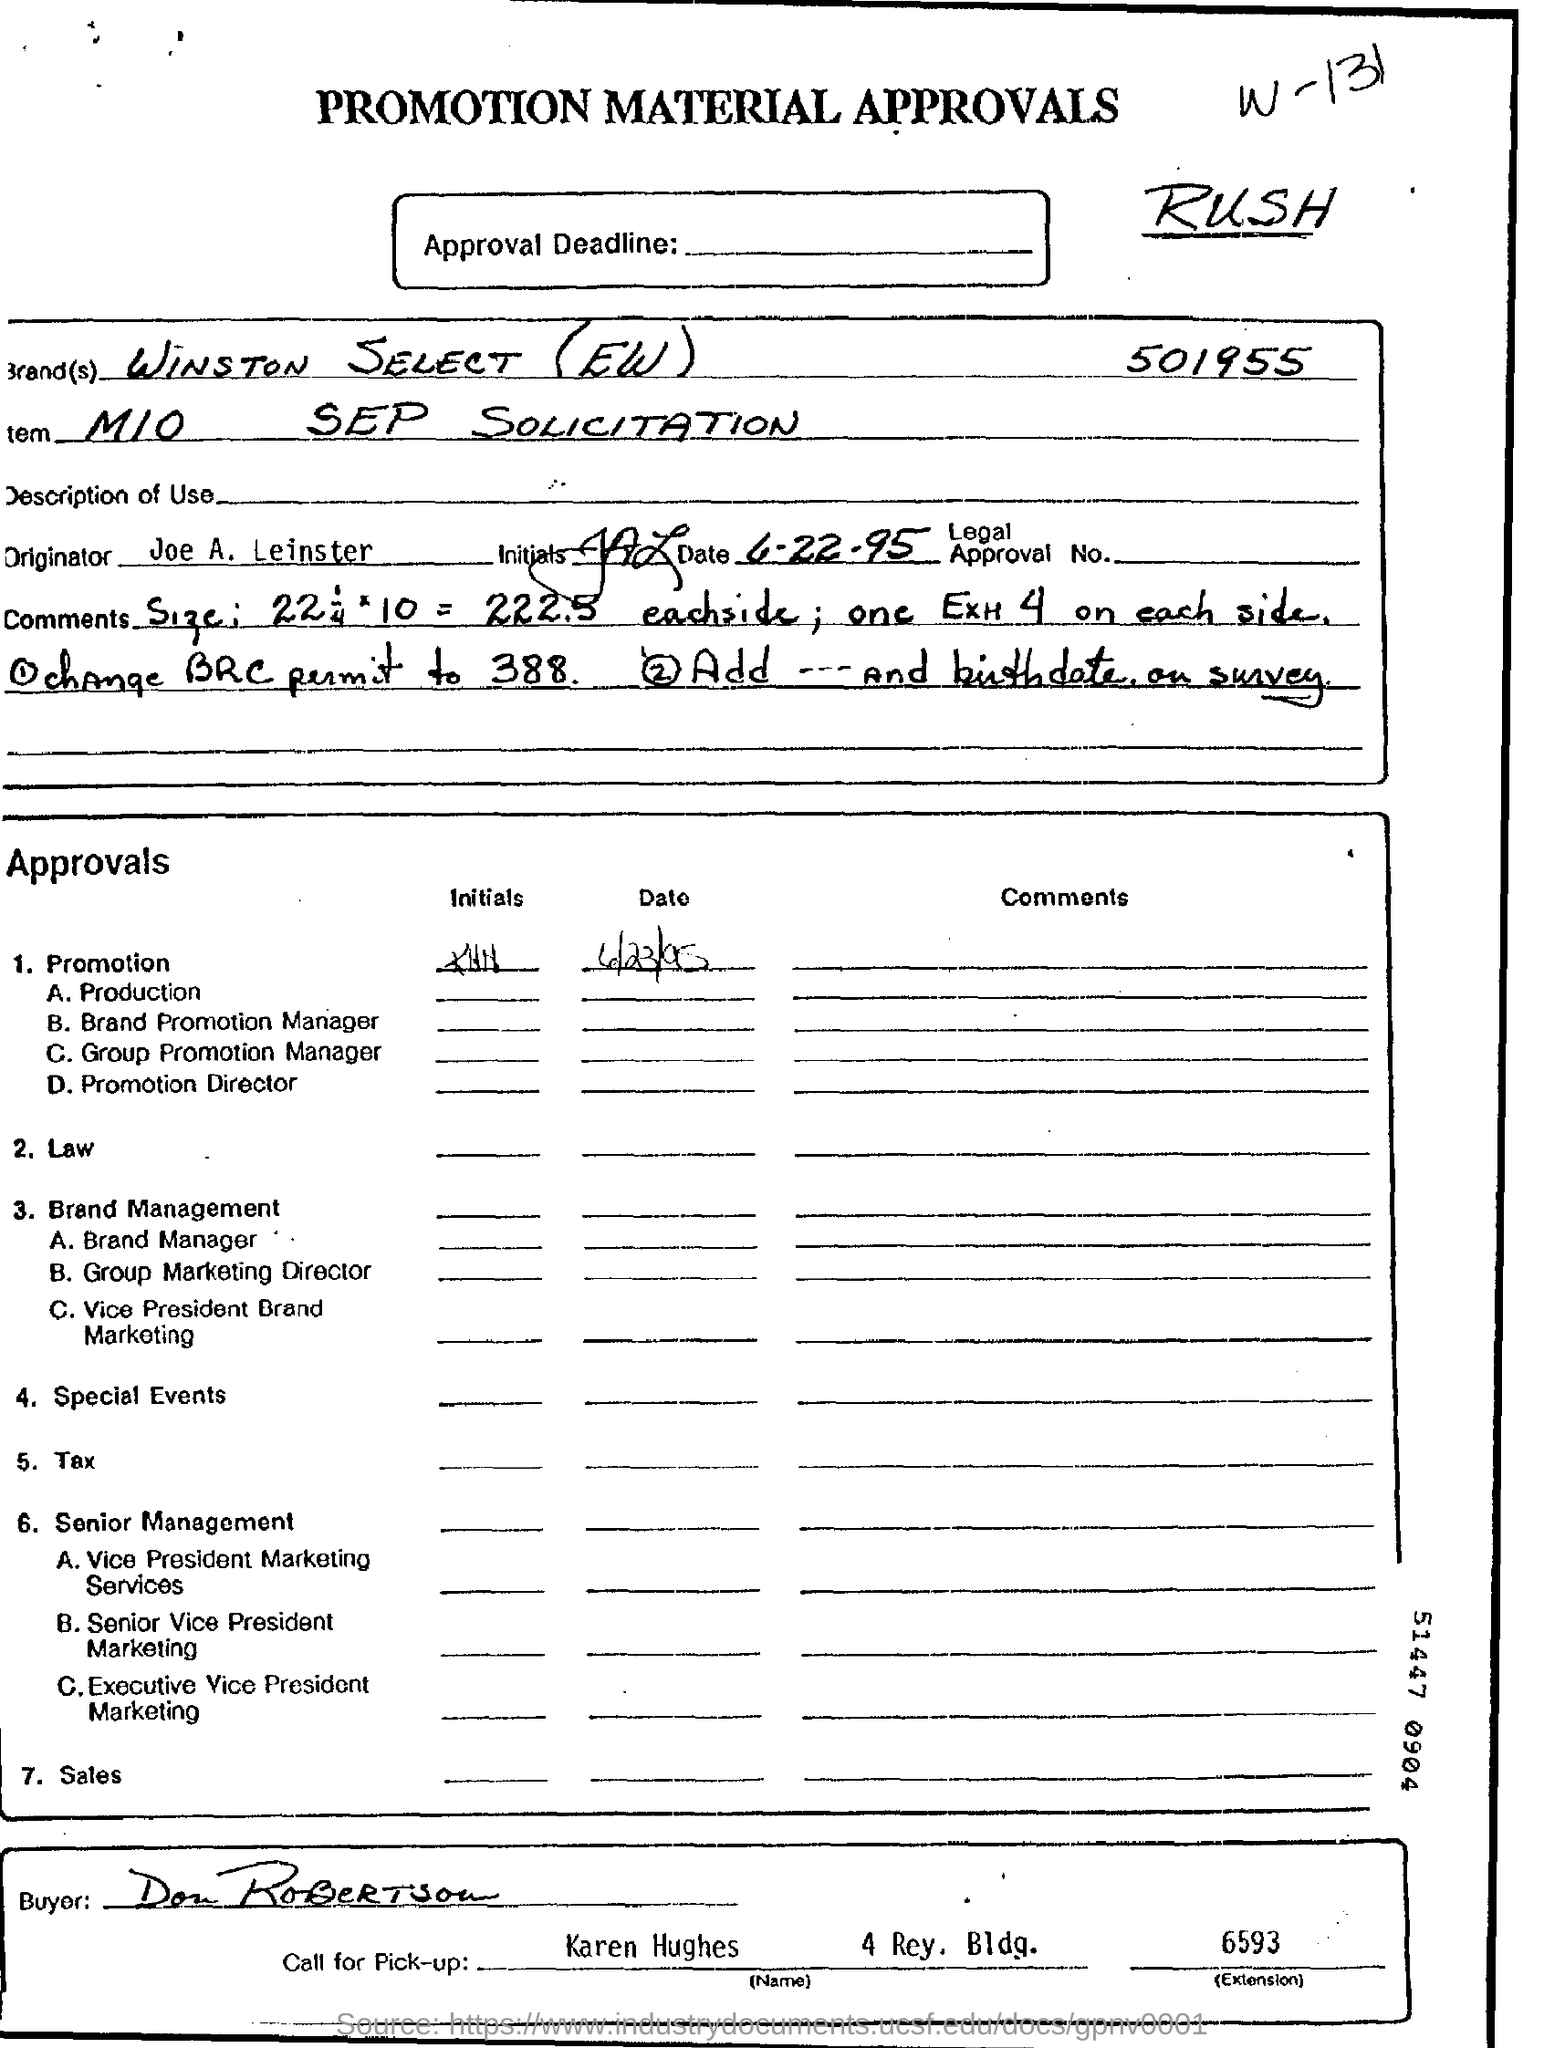What is the date on the document?
Ensure brevity in your answer.  6-22-95. Who is the Buyer?
Provide a succinct answer. Don Robertson. Who is the "Call for Pick-Up" person?
Make the answer very short. Karen Hughes. 